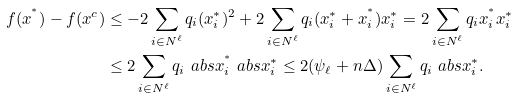Convert formula to latex. <formula><loc_0><loc_0><loc_500><loc_500>f ( x ^ { ^ { * } } ) - f ( x ^ { c } ) & \leq - 2 \sum _ { i \in N ^ { \ell } } q _ { i } ( x ^ { * } _ { i } ) ^ { 2 } + 2 \sum _ { i \in N ^ { \ell } } q _ { i } ( x ^ { * } _ { i } + x ^ { ^ { * } } _ { i } ) x ^ { * } _ { i } = 2 \sum _ { i \in N ^ { \ell } } q _ { i } x ^ { ^ { * } } _ { i } x ^ { * } _ { i } \\ & \leq 2 \sum _ { i \in N ^ { \ell } } q _ { i } \ a b s { x ^ { ^ { * } } _ { i } } \ a b s { x ^ { * } _ { i } } \leq 2 ( \psi _ { \ell } + n \Delta ) \sum _ { i \in N ^ { \ell } } q _ { i } \ a b s { x ^ { * } _ { i } } .</formula> 